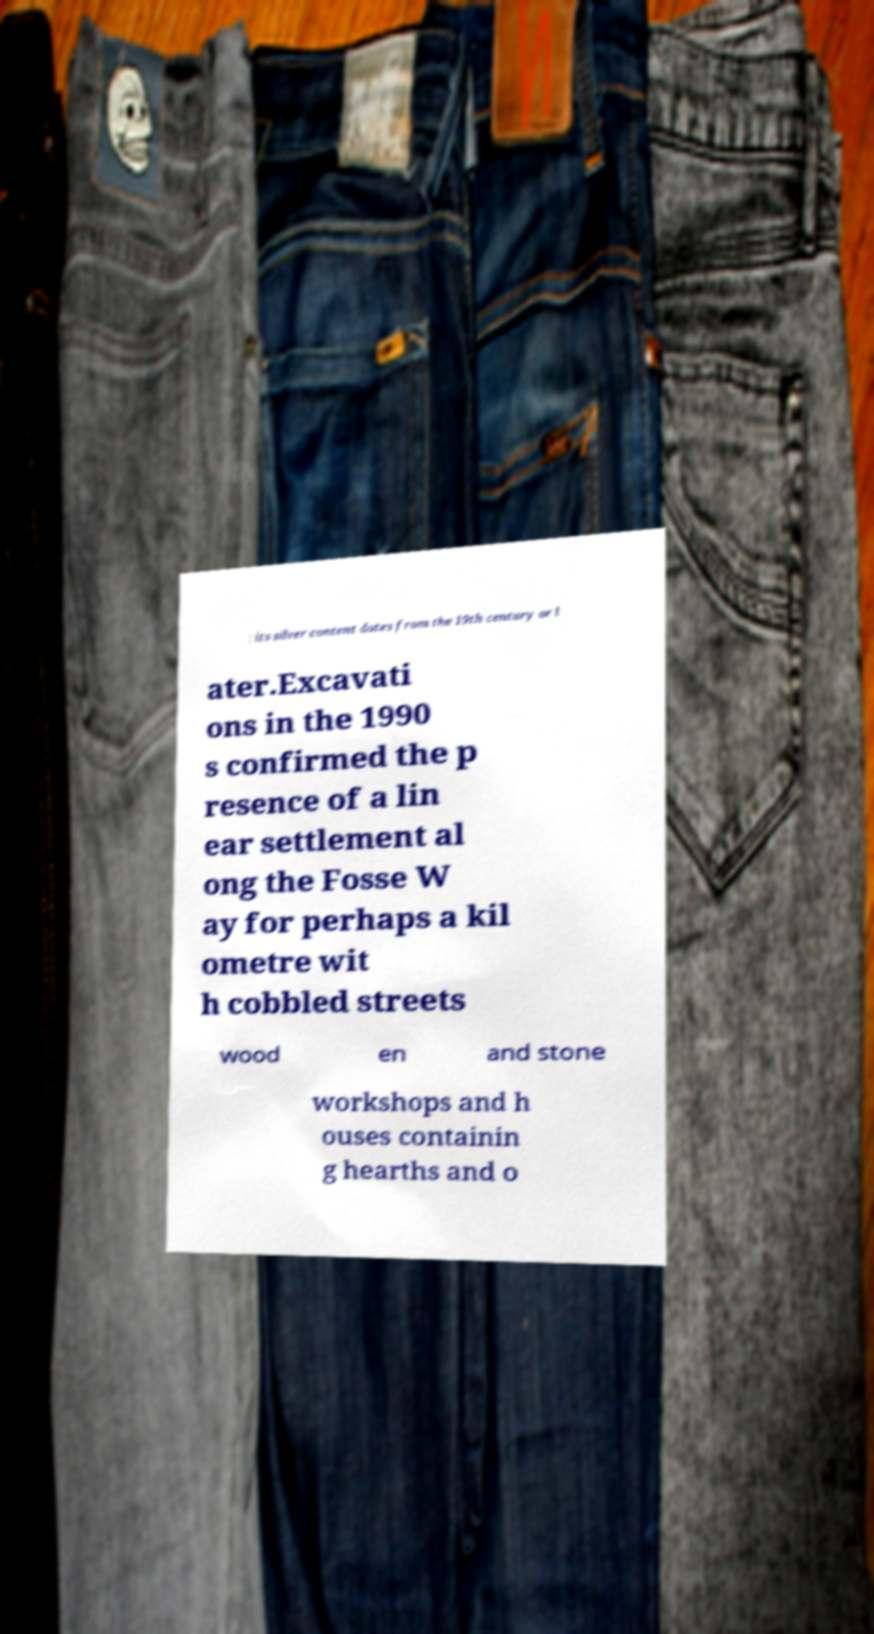Could you assist in decoding the text presented in this image and type it out clearly? : its silver content dates from the 19th century or l ater.Excavati ons in the 1990 s confirmed the p resence of a lin ear settlement al ong the Fosse W ay for perhaps a kil ometre wit h cobbled streets wood en and stone workshops and h ouses containin g hearths and o 